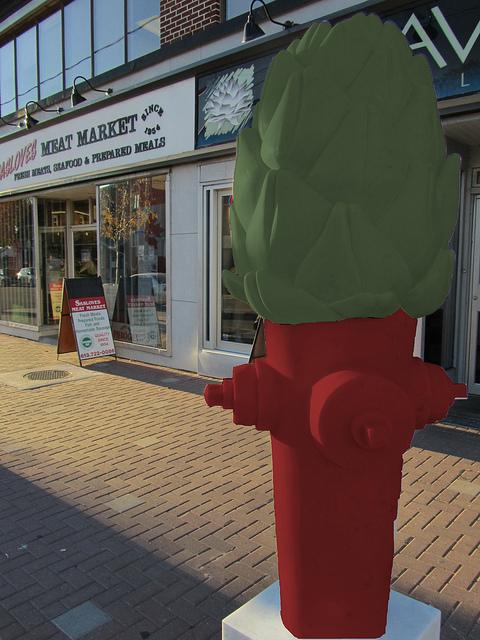Is it raining?
Be succinct. No. What kind of market is in the background?
Write a very short answer. Meat. What is the hydrant used for?
Quick response, please. Water. Are there any vehicles in this photo?
Give a very brief answer. No. Where are they?
Write a very short answer. Market. What does the street sign say?
Be succinct. Meat market. What color is the fire hydrant?
Give a very brief answer. Red. What is the top of the hydrants color?
Concise answer only. Green. What does the fire hydrants represent?
Write a very short answer. Artichoke. Does the fire hydrant work?
Short answer required. No. What material is the pathway constructed of?
Concise answer only. Brick. Is the fire hydrant real?
Be succinct. No. What color is the sign above the door?
Give a very brief answer. White. 